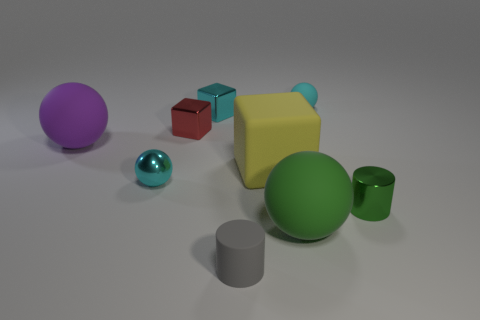Subtract all cyan metal cubes. How many cubes are left? 2 Subtract all yellow blocks. How many cyan balls are left? 2 Subtract all green cylinders. How many cylinders are left? 1 Subtract all blocks. How many objects are left? 6 Add 7 shiny balls. How many shiny balls are left? 8 Add 1 big purple rubber spheres. How many big purple rubber spheres exist? 2 Subtract 1 gray cylinders. How many objects are left? 8 Subtract all gray spheres. Subtract all cyan blocks. How many spheres are left? 4 Subtract all tiny purple matte balls. Subtract all shiny cubes. How many objects are left? 7 